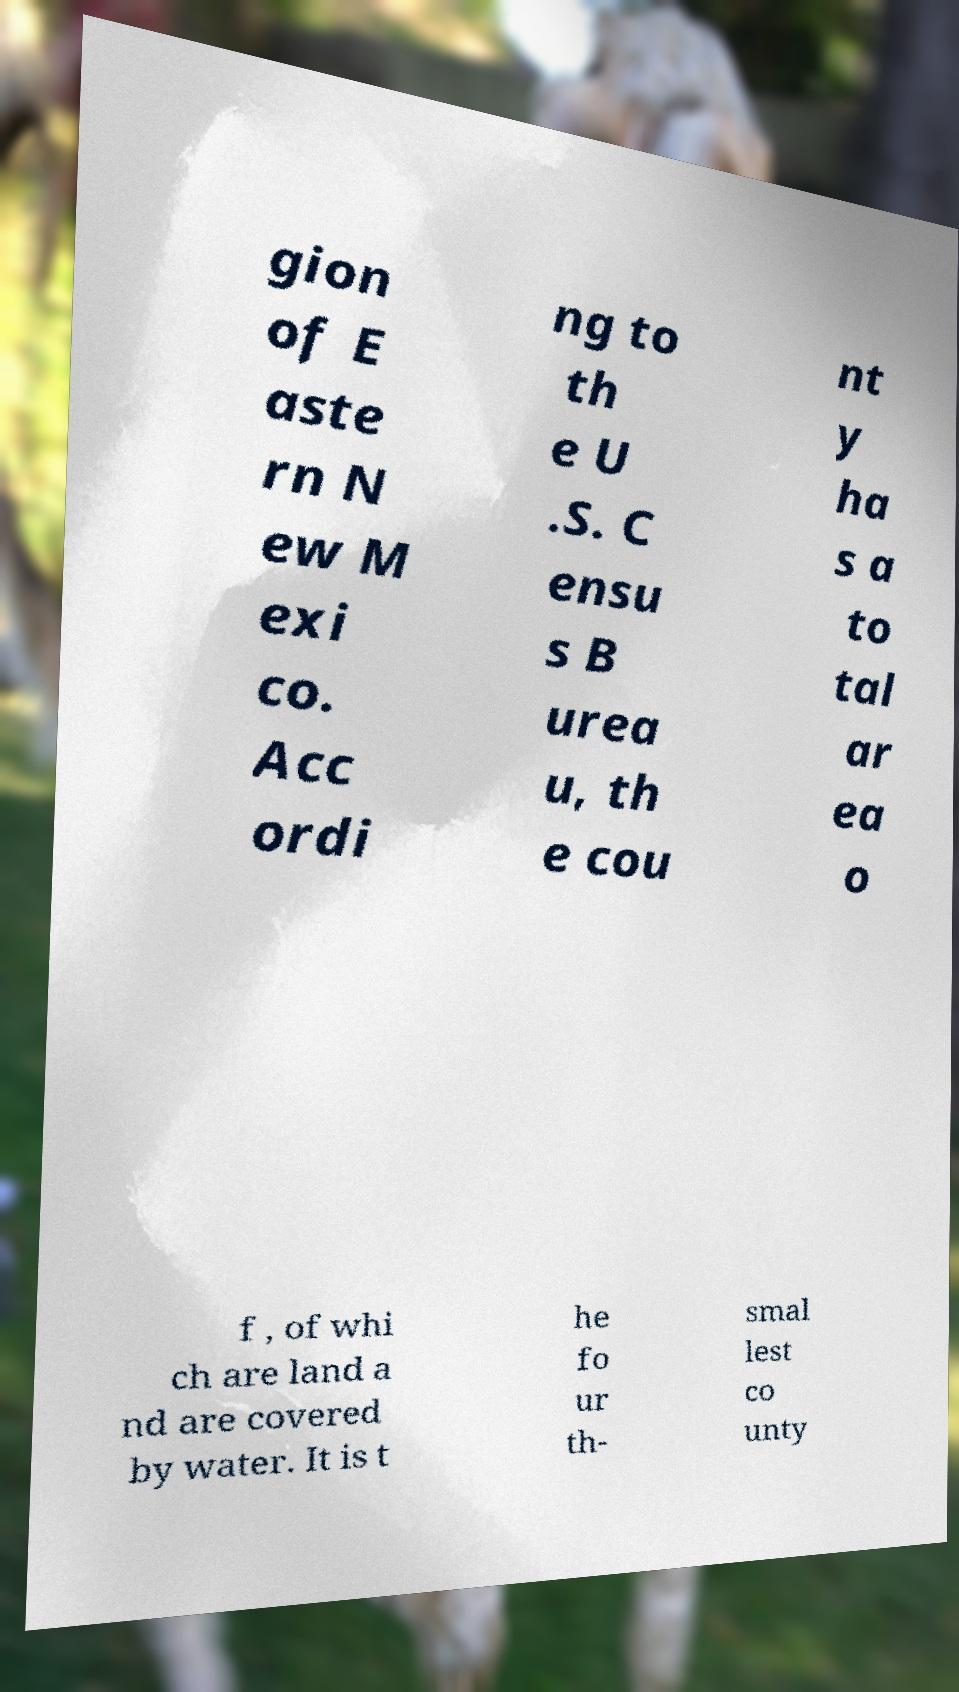I need the written content from this picture converted into text. Can you do that? gion of E aste rn N ew M exi co. Acc ordi ng to th e U .S. C ensu s B urea u, th e cou nt y ha s a to tal ar ea o f , of whi ch are land a nd are covered by water. It is t he fo ur th- smal lest co unty 